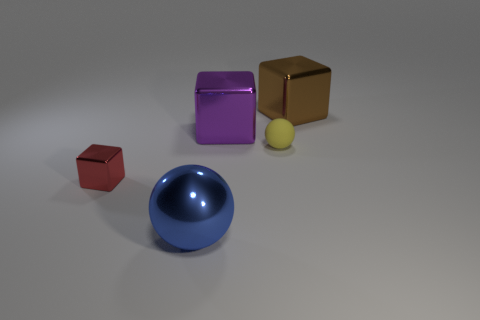Is there a red cube?
Offer a very short reply. Yes. Is there a small shiny thing behind the small object on the left side of the blue sphere?
Ensure brevity in your answer.  No. What is the material of the blue thing that is the same shape as the tiny yellow thing?
Give a very brief answer. Metal. Are there more small blocks than large blue matte cylinders?
Your response must be concise. Yes. Do the tiny shiny cube and the big cube to the left of the small sphere have the same color?
Ensure brevity in your answer.  No. There is a big shiny thing that is on the left side of the tiny matte sphere and behind the blue metallic ball; what is its color?
Your answer should be compact. Purple. How many other things are the same material as the brown cube?
Your response must be concise. 3. Are there fewer shiny cylinders than purple cubes?
Offer a terse response. Yes. Do the large blue sphere and the big block that is in front of the brown object have the same material?
Your response must be concise. Yes. What shape is the metallic object that is on the left side of the large metal ball?
Your response must be concise. Cube. 